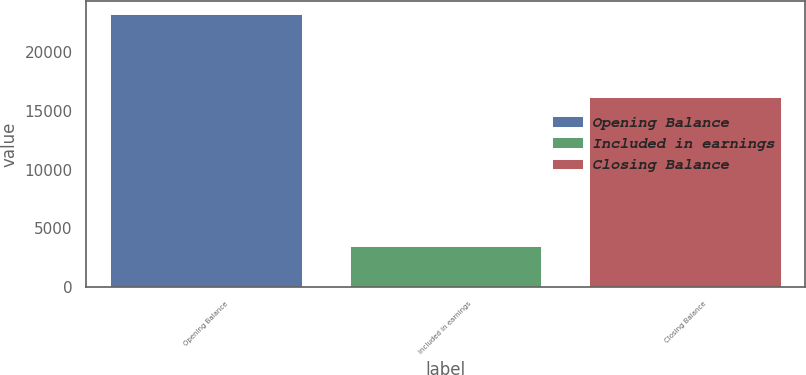Convert chart. <chart><loc_0><loc_0><loc_500><loc_500><bar_chart><fcel>Opening Balance<fcel>Included in earnings<fcel>Closing Balance<nl><fcel>23156<fcel>3553<fcel>16184<nl></chart> 